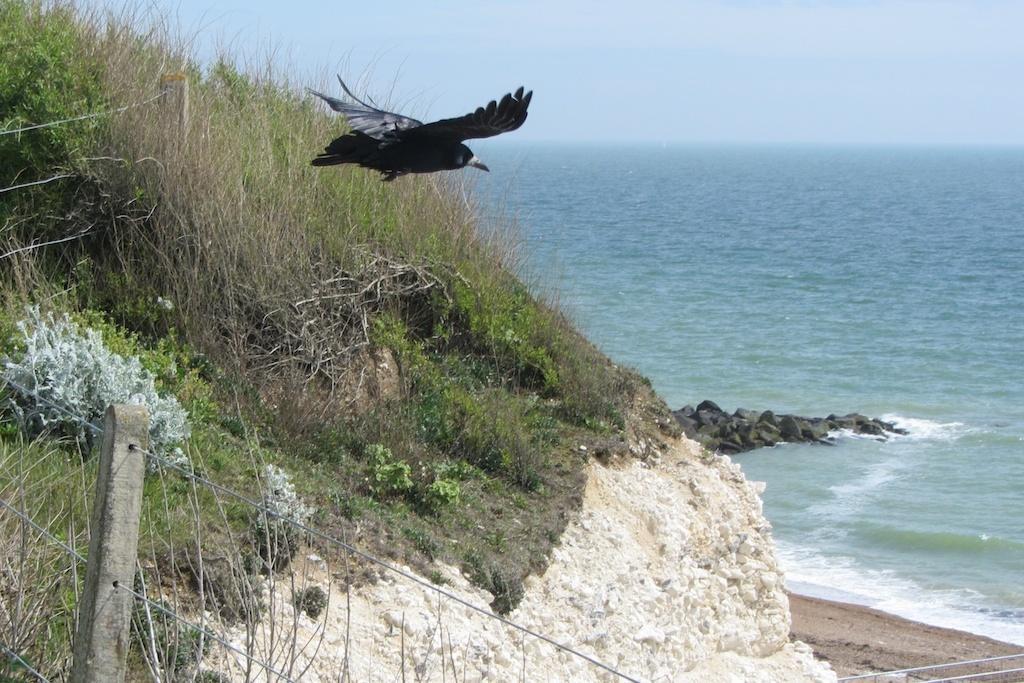In one or two sentences, can you explain what this image depicts? In this image, we can see a bird and some water. We can also see the ground and a hill. We can see some grass, plants. We can also see the fence and the sky. 